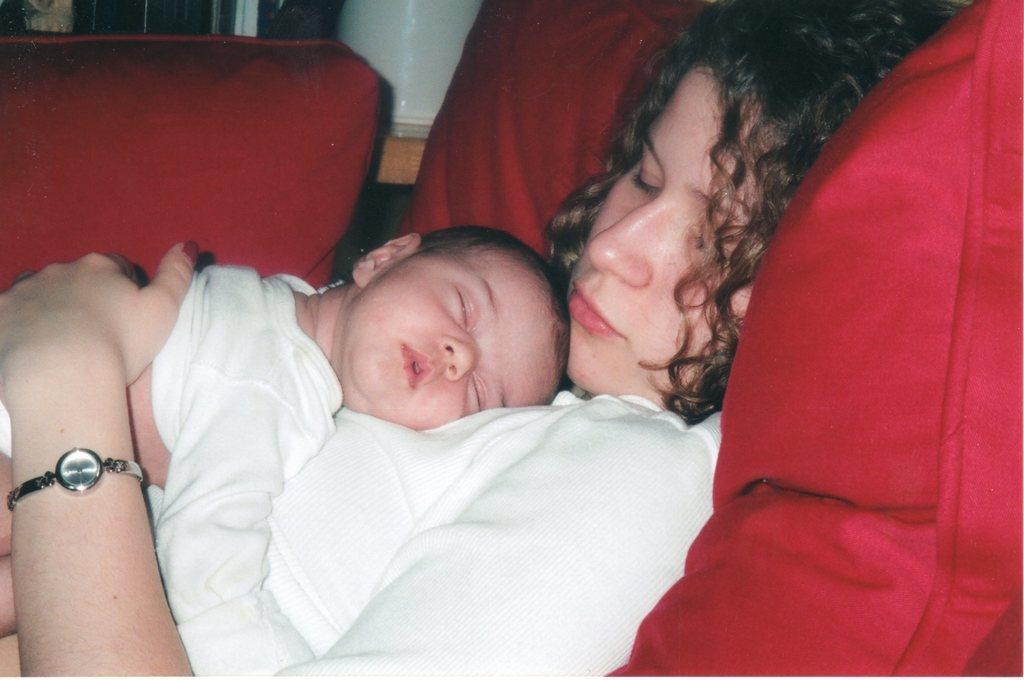In one or two sentences, can you explain what this image depicts? This image consists of a woman and a kid both are wearing white dresses. They are sleeping. On the right, we can see a pillow in red color. In the background, there is a window. 